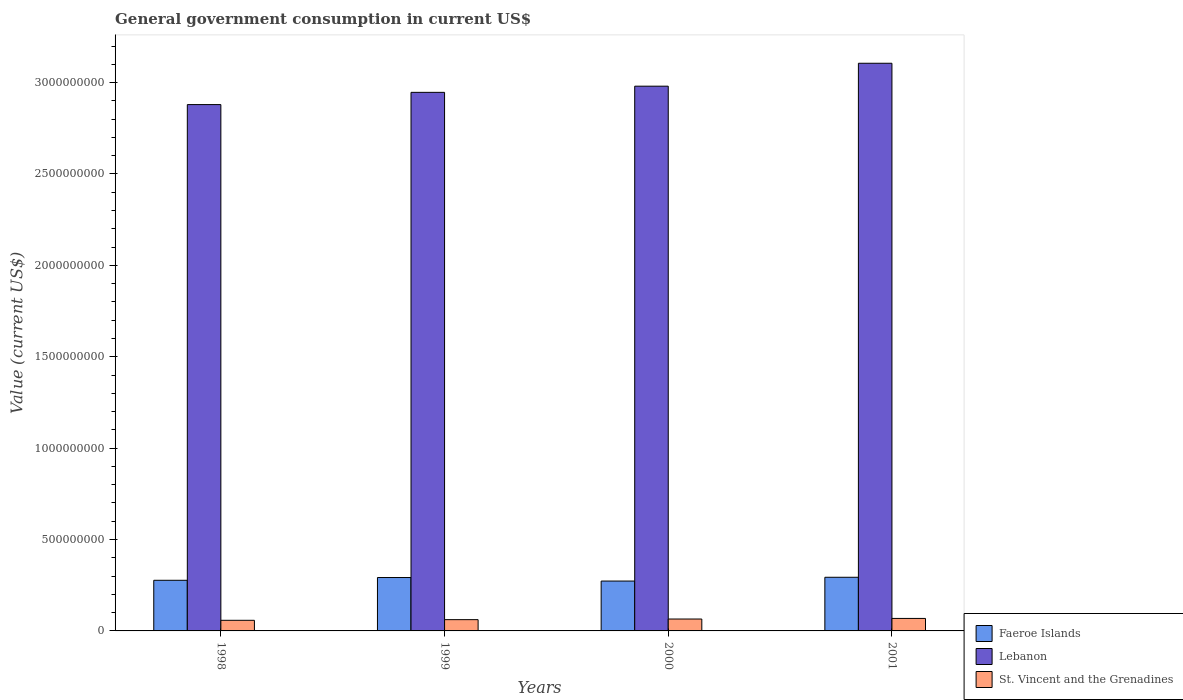How many different coloured bars are there?
Your answer should be very brief. 3. Are the number of bars per tick equal to the number of legend labels?
Give a very brief answer. Yes. How many bars are there on the 2nd tick from the right?
Offer a terse response. 3. What is the government conusmption in Lebanon in 2000?
Your answer should be very brief. 2.98e+09. Across all years, what is the maximum government conusmption in Lebanon?
Provide a succinct answer. 3.11e+09. Across all years, what is the minimum government conusmption in St. Vincent and the Grenadines?
Make the answer very short. 5.81e+07. In which year was the government conusmption in Faeroe Islands minimum?
Your answer should be compact. 2000. What is the total government conusmption in Lebanon in the graph?
Your answer should be compact. 1.19e+1. What is the difference between the government conusmption in Lebanon in 1999 and that in 2001?
Your answer should be very brief. -1.59e+08. What is the difference between the government conusmption in Lebanon in 2000 and the government conusmption in St. Vincent and the Grenadines in 1998?
Make the answer very short. 2.92e+09. What is the average government conusmption in Lebanon per year?
Your answer should be compact. 2.98e+09. In the year 1998, what is the difference between the government conusmption in Lebanon and government conusmption in St. Vincent and the Grenadines?
Provide a short and direct response. 2.82e+09. What is the ratio of the government conusmption in Lebanon in 1999 to that in 2001?
Provide a short and direct response. 0.95. Is the difference between the government conusmption in Lebanon in 1999 and 2000 greater than the difference between the government conusmption in St. Vincent and the Grenadines in 1999 and 2000?
Ensure brevity in your answer.  No. What is the difference between the highest and the second highest government conusmption in Faeroe Islands?
Provide a succinct answer. 1.39e+06. What is the difference between the highest and the lowest government conusmption in St. Vincent and the Grenadines?
Provide a short and direct response. 1.03e+07. In how many years, is the government conusmption in Lebanon greater than the average government conusmption in Lebanon taken over all years?
Give a very brief answer. 2. What does the 1st bar from the left in 2000 represents?
Offer a very short reply. Faeroe Islands. What does the 2nd bar from the right in 2001 represents?
Provide a succinct answer. Lebanon. How many bars are there?
Provide a succinct answer. 12. Are all the bars in the graph horizontal?
Give a very brief answer. No. How many years are there in the graph?
Ensure brevity in your answer.  4. What is the difference between two consecutive major ticks on the Y-axis?
Offer a very short reply. 5.00e+08. Are the values on the major ticks of Y-axis written in scientific E-notation?
Ensure brevity in your answer.  No. Does the graph contain any zero values?
Ensure brevity in your answer.  No. How many legend labels are there?
Keep it short and to the point. 3. What is the title of the graph?
Your response must be concise. General government consumption in current US$. What is the label or title of the X-axis?
Keep it short and to the point. Years. What is the label or title of the Y-axis?
Provide a short and direct response. Value (current US$). What is the Value (current US$) of Faeroe Islands in 1998?
Provide a short and direct response. 2.77e+08. What is the Value (current US$) in Lebanon in 1998?
Keep it short and to the point. 2.88e+09. What is the Value (current US$) in St. Vincent and the Grenadines in 1998?
Your answer should be very brief. 5.81e+07. What is the Value (current US$) in Faeroe Islands in 1999?
Your answer should be compact. 2.92e+08. What is the Value (current US$) in Lebanon in 1999?
Your answer should be compact. 2.95e+09. What is the Value (current US$) in St. Vincent and the Grenadines in 1999?
Your answer should be very brief. 6.17e+07. What is the Value (current US$) in Faeroe Islands in 2000?
Ensure brevity in your answer.  2.73e+08. What is the Value (current US$) in Lebanon in 2000?
Keep it short and to the point. 2.98e+09. What is the Value (current US$) in St. Vincent and the Grenadines in 2000?
Your answer should be compact. 6.51e+07. What is the Value (current US$) in Faeroe Islands in 2001?
Ensure brevity in your answer.  2.94e+08. What is the Value (current US$) in Lebanon in 2001?
Your answer should be compact. 3.11e+09. What is the Value (current US$) in St. Vincent and the Grenadines in 2001?
Offer a terse response. 6.84e+07. Across all years, what is the maximum Value (current US$) in Faeroe Islands?
Your response must be concise. 2.94e+08. Across all years, what is the maximum Value (current US$) in Lebanon?
Keep it short and to the point. 3.11e+09. Across all years, what is the maximum Value (current US$) of St. Vincent and the Grenadines?
Keep it short and to the point. 6.84e+07. Across all years, what is the minimum Value (current US$) of Faeroe Islands?
Offer a terse response. 2.73e+08. Across all years, what is the minimum Value (current US$) of Lebanon?
Give a very brief answer. 2.88e+09. Across all years, what is the minimum Value (current US$) of St. Vincent and the Grenadines?
Provide a short and direct response. 5.81e+07. What is the total Value (current US$) of Faeroe Islands in the graph?
Provide a succinct answer. 1.14e+09. What is the total Value (current US$) in Lebanon in the graph?
Make the answer very short. 1.19e+1. What is the total Value (current US$) in St. Vincent and the Grenadines in the graph?
Your response must be concise. 2.53e+08. What is the difference between the Value (current US$) of Faeroe Islands in 1998 and that in 1999?
Your answer should be very brief. -1.52e+07. What is the difference between the Value (current US$) of Lebanon in 1998 and that in 1999?
Keep it short and to the point. -6.69e+07. What is the difference between the Value (current US$) in St. Vincent and the Grenadines in 1998 and that in 1999?
Offer a terse response. -3.62e+06. What is the difference between the Value (current US$) in Faeroe Islands in 1998 and that in 2000?
Offer a very short reply. 4.19e+06. What is the difference between the Value (current US$) in Lebanon in 1998 and that in 2000?
Give a very brief answer. -1.01e+08. What is the difference between the Value (current US$) in St. Vincent and the Grenadines in 1998 and that in 2000?
Ensure brevity in your answer.  -7.06e+06. What is the difference between the Value (current US$) in Faeroe Islands in 1998 and that in 2001?
Make the answer very short. -1.65e+07. What is the difference between the Value (current US$) in Lebanon in 1998 and that in 2001?
Your answer should be compact. -2.26e+08. What is the difference between the Value (current US$) of St. Vincent and the Grenadines in 1998 and that in 2001?
Make the answer very short. -1.03e+07. What is the difference between the Value (current US$) of Faeroe Islands in 1999 and that in 2000?
Ensure brevity in your answer.  1.93e+07. What is the difference between the Value (current US$) of Lebanon in 1999 and that in 2000?
Provide a short and direct response. -3.38e+07. What is the difference between the Value (current US$) in St. Vincent and the Grenadines in 1999 and that in 2000?
Keep it short and to the point. -3.44e+06. What is the difference between the Value (current US$) of Faeroe Islands in 1999 and that in 2001?
Ensure brevity in your answer.  -1.39e+06. What is the difference between the Value (current US$) in Lebanon in 1999 and that in 2001?
Offer a terse response. -1.59e+08. What is the difference between the Value (current US$) in St. Vincent and the Grenadines in 1999 and that in 2001?
Provide a succinct answer. -6.70e+06. What is the difference between the Value (current US$) in Faeroe Islands in 2000 and that in 2001?
Keep it short and to the point. -2.07e+07. What is the difference between the Value (current US$) of Lebanon in 2000 and that in 2001?
Your response must be concise. -1.25e+08. What is the difference between the Value (current US$) of St. Vincent and the Grenadines in 2000 and that in 2001?
Your response must be concise. -3.26e+06. What is the difference between the Value (current US$) of Faeroe Islands in 1998 and the Value (current US$) of Lebanon in 1999?
Offer a terse response. -2.67e+09. What is the difference between the Value (current US$) in Faeroe Islands in 1998 and the Value (current US$) in St. Vincent and the Grenadines in 1999?
Offer a very short reply. 2.15e+08. What is the difference between the Value (current US$) in Lebanon in 1998 and the Value (current US$) in St. Vincent and the Grenadines in 1999?
Your response must be concise. 2.82e+09. What is the difference between the Value (current US$) in Faeroe Islands in 1998 and the Value (current US$) in Lebanon in 2000?
Provide a succinct answer. -2.70e+09. What is the difference between the Value (current US$) in Faeroe Islands in 1998 and the Value (current US$) in St. Vincent and the Grenadines in 2000?
Ensure brevity in your answer.  2.12e+08. What is the difference between the Value (current US$) of Lebanon in 1998 and the Value (current US$) of St. Vincent and the Grenadines in 2000?
Give a very brief answer. 2.81e+09. What is the difference between the Value (current US$) in Faeroe Islands in 1998 and the Value (current US$) in Lebanon in 2001?
Keep it short and to the point. -2.83e+09. What is the difference between the Value (current US$) in Faeroe Islands in 1998 and the Value (current US$) in St. Vincent and the Grenadines in 2001?
Offer a very short reply. 2.09e+08. What is the difference between the Value (current US$) in Lebanon in 1998 and the Value (current US$) in St. Vincent and the Grenadines in 2001?
Offer a terse response. 2.81e+09. What is the difference between the Value (current US$) in Faeroe Islands in 1999 and the Value (current US$) in Lebanon in 2000?
Give a very brief answer. -2.69e+09. What is the difference between the Value (current US$) in Faeroe Islands in 1999 and the Value (current US$) in St. Vincent and the Grenadines in 2000?
Ensure brevity in your answer.  2.27e+08. What is the difference between the Value (current US$) of Lebanon in 1999 and the Value (current US$) of St. Vincent and the Grenadines in 2000?
Keep it short and to the point. 2.88e+09. What is the difference between the Value (current US$) of Faeroe Islands in 1999 and the Value (current US$) of Lebanon in 2001?
Offer a terse response. -2.81e+09. What is the difference between the Value (current US$) in Faeroe Islands in 1999 and the Value (current US$) in St. Vincent and the Grenadines in 2001?
Keep it short and to the point. 2.24e+08. What is the difference between the Value (current US$) of Lebanon in 1999 and the Value (current US$) of St. Vincent and the Grenadines in 2001?
Your answer should be very brief. 2.88e+09. What is the difference between the Value (current US$) of Faeroe Islands in 2000 and the Value (current US$) of Lebanon in 2001?
Your answer should be compact. -2.83e+09. What is the difference between the Value (current US$) in Faeroe Islands in 2000 and the Value (current US$) in St. Vincent and the Grenadines in 2001?
Your response must be concise. 2.04e+08. What is the difference between the Value (current US$) of Lebanon in 2000 and the Value (current US$) of St. Vincent and the Grenadines in 2001?
Your response must be concise. 2.91e+09. What is the average Value (current US$) in Faeroe Islands per year?
Offer a terse response. 2.84e+08. What is the average Value (current US$) in Lebanon per year?
Your answer should be very brief. 2.98e+09. What is the average Value (current US$) of St. Vincent and the Grenadines per year?
Your answer should be compact. 6.33e+07. In the year 1998, what is the difference between the Value (current US$) in Faeroe Islands and Value (current US$) in Lebanon?
Make the answer very short. -2.60e+09. In the year 1998, what is the difference between the Value (current US$) of Faeroe Islands and Value (current US$) of St. Vincent and the Grenadines?
Your answer should be compact. 2.19e+08. In the year 1998, what is the difference between the Value (current US$) of Lebanon and Value (current US$) of St. Vincent and the Grenadines?
Offer a terse response. 2.82e+09. In the year 1999, what is the difference between the Value (current US$) in Faeroe Islands and Value (current US$) in Lebanon?
Provide a short and direct response. -2.65e+09. In the year 1999, what is the difference between the Value (current US$) in Faeroe Islands and Value (current US$) in St. Vincent and the Grenadines?
Offer a terse response. 2.30e+08. In the year 1999, what is the difference between the Value (current US$) of Lebanon and Value (current US$) of St. Vincent and the Grenadines?
Your answer should be compact. 2.88e+09. In the year 2000, what is the difference between the Value (current US$) of Faeroe Islands and Value (current US$) of Lebanon?
Provide a short and direct response. -2.71e+09. In the year 2000, what is the difference between the Value (current US$) of Faeroe Islands and Value (current US$) of St. Vincent and the Grenadines?
Provide a succinct answer. 2.08e+08. In the year 2000, what is the difference between the Value (current US$) in Lebanon and Value (current US$) in St. Vincent and the Grenadines?
Offer a terse response. 2.92e+09. In the year 2001, what is the difference between the Value (current US$) in Faeroe Islands and Value (current US$) in Lebanon?
Your response must be concise. -2.81e+09. In the year 2001, what is the difference between the Value (current US$) of Faeroe Islands and Value (current US$) of St. Vincent and the Grenadines?
Keep it short and to the point. 2.25e+08. In the year 2001, what is the difference between the Value (current US$) in Lebanon and Value (current US$) in St. Vincent and the Grenadines?
Ensure brevity in your answer.  3.04e+09. What is the ratio of the Value (current US$) in Faeroe Islands in 1998 to that in 1999?
Your answer should be very brief. 0.95. What is the ratio of the Value (current US$) in Lebanon in 1998 to that in 1999?
Keep it short and to the point. 0.98. What is the ratio of the Value (current US$) of St. Vincent and the Grenadines in 1998 to that in 1999?
Offer a very short reply. 0.94. What is the ratio of the Value (current US$) of Faeroe Islands in 1998 to that in 2000?
Make the answer very short. 1.02. What is the ratio of the Value (current US$) in Lebanon in 1998 to that in 2000?
Give a very brief answer. 0.97. What is the ratio of the Value (current US$) in St. Vincent and the Grenadines in 1998 to that in 2000?
Provide a short and direct response. 0.89. What is the ratio of the Value (current US$) of Faeroe Islands in 1998 to that in 2001?
Offer a terse response. 0.94. What is the ratio of the Value (current US$) of Lebanon in 1998 to that in 2001?
Give a very brief answer. 0.93. What is the ratio of the Value (current US$) in St. Vincent and the Grenadines in 1998 to that in 2001?
Ensure brevity in your answer.  0.85. What is the ratio of the Value (current US$) of Faeroe Islands in 1999 to that in 2000?
Ensure brevity in your answer.  1.07. What is the ratio of the Value (current US$) of Lebanon in 1999 to that in 2000?
Ensure brevity in your answer.  0.99. What is the ratio of the Value (current US$) of St. Vincent and the Grenadines in 1999 to that in 2000?
Ensure brevity in your answer.  0.95. What is the ratio of the Value (current US$) in Lebanon in 1999 to that in 2001?
Keep it short and to the point. 0.95. What is the ratio of the Value (current US$) of St. Vincent and the Grenadines in 1999 to that in 2001?
Offer a terse response. 0.9. What is the ratio of the Value (current US$) in Faeroe Islands in 2000 to that in 2001?
Provide a succinct answer. 0.93. What is the ratio of the Value (current US$) of Lebanon in 2000 to that in 2001?
Your answer should be very brief. 0.96. What is the ratio of the Value (current US$) of St. Vincent and the Grenadines in 2000 to that in 2001?
Your answer should be compact. 0.95. What is the difference between the highest and the second highest Value (current US$) of Faeroe Islands?
Your answer should be very brief. 1.39e+06. What is the difference between the highest and the second highest Value (current US$) in Lebanon?
Make the answer very short. 1.25e+08. What is the difference between the highest and the second highest Value (current US$) of St. Vincent and the Grenadines?
Your response must be concise. 3.26e+06. What is the difference between the highest and the lowest Value (current US$) of Faeroe Islands?
Your response must be concise. 2.07e+07. What is the difference between the highest and the lowest Value (current US$) of Lebanon?
Give a very brief answer. 2.26e+08. What is the difference between the highest and the lowest Value (current US$) in St. Vincent and the Grenadines?
Provide a short and direct response. 1.03e+07. 